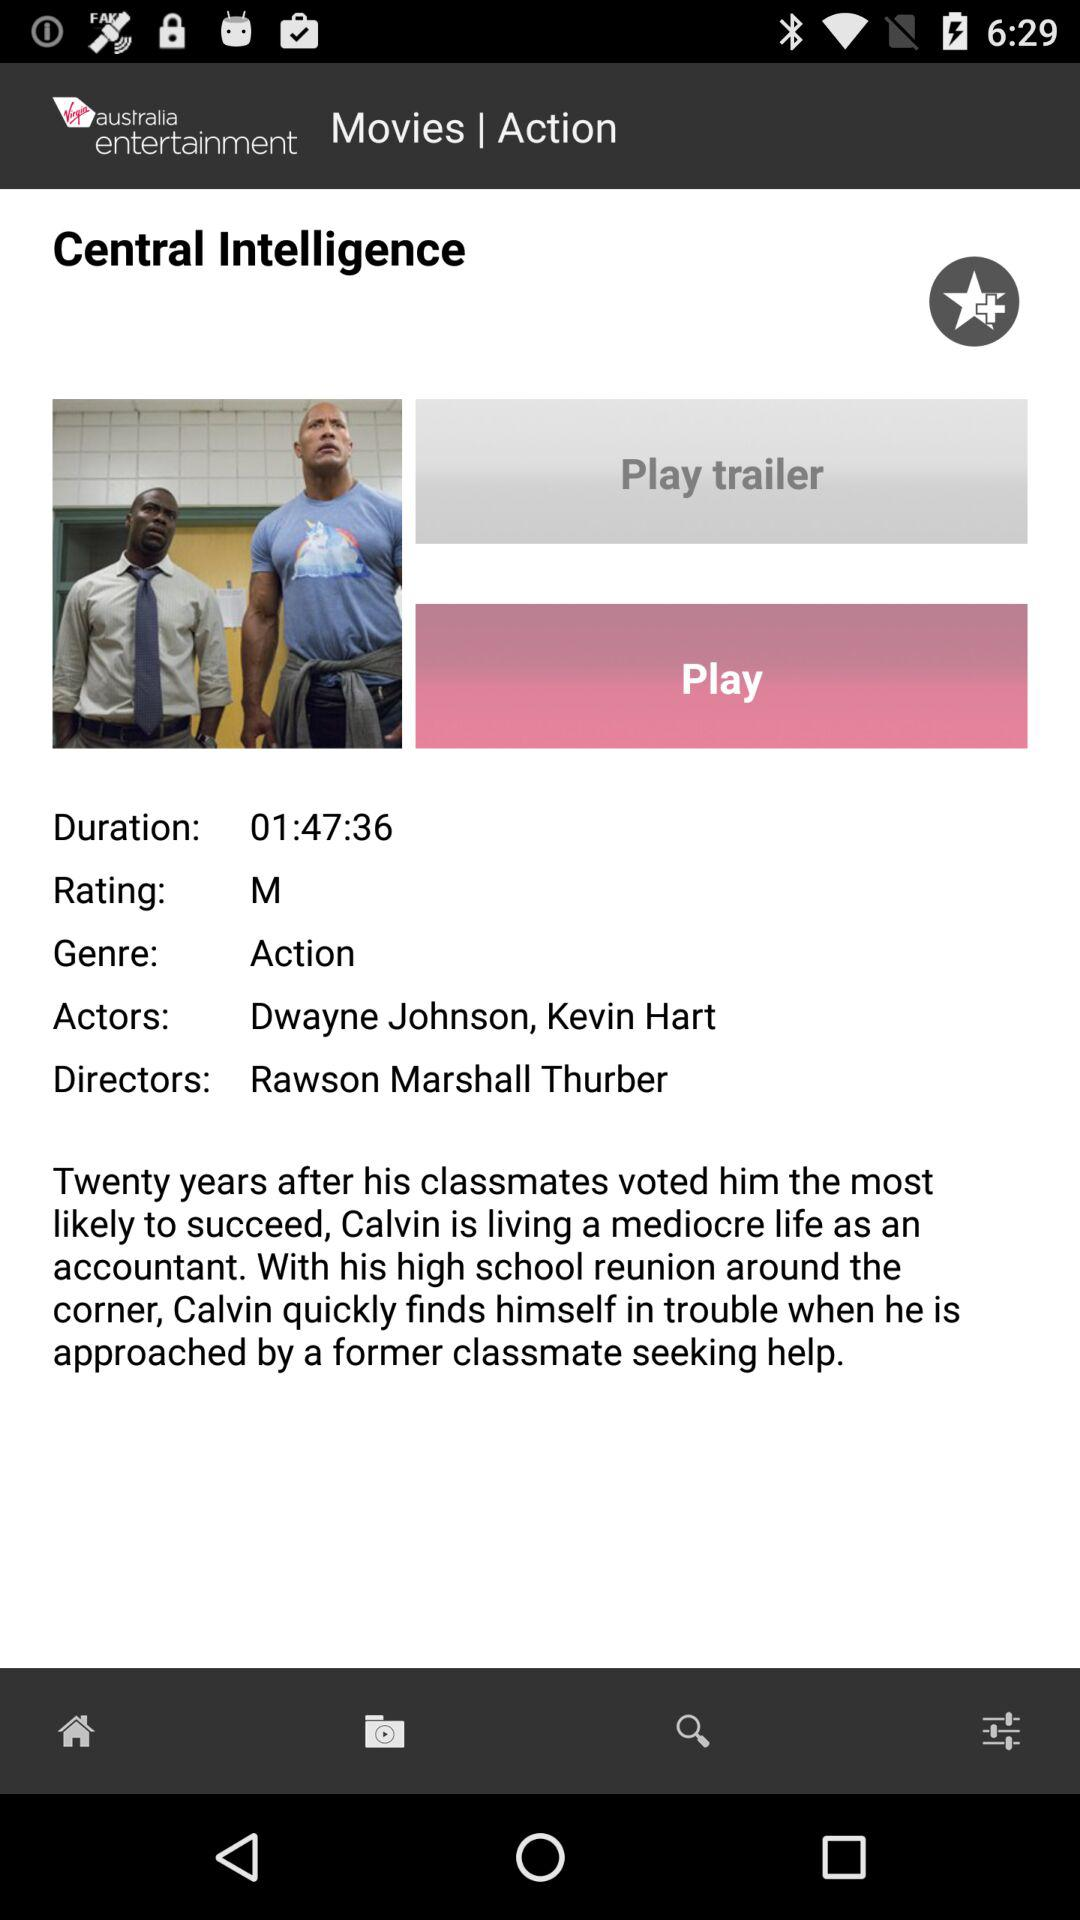What is the duration of the movie? The duration of the movie is 1 hour, 47 minutes and 36 seconds. 